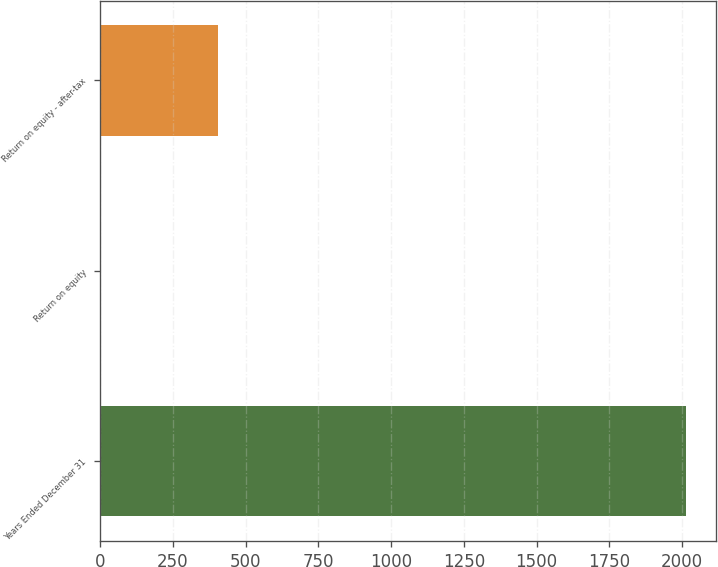Convert chart to OTSL. <chart><loc_0><loc_0><loc_500><loc_500><bar_chart><fcel>Years Ended December 31<fcel>Return on equity<fcel>Return on equity - after-tax<nl><fcel>2015<fcel>2.2<fcel>404.76<nl></chart> 